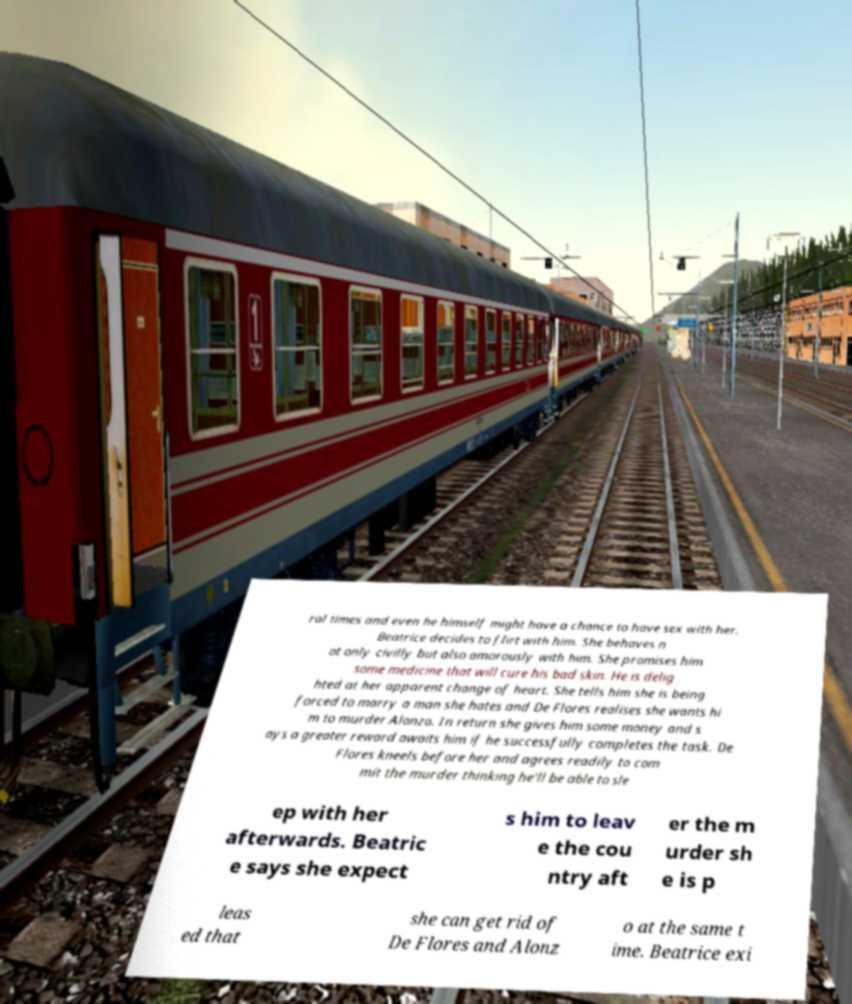What messages or text are displayed in this image? I need them in a readable, typed format. ral times and even he himself might have a chance to have sex with her. Beatrice decides to flirt with him. She behaves n ot only civilly but also amorously with him. She promises him some medicine that will cure his bad skin. He is delig hted at her apparent change of heart. She tells him she is being forced to marry a man she hates and De Flores realises she wants hi m to murder Alonzo. In return she gives him some money and s ays a greater reward awaits him if he successfully completes the task. De Flores kneels before her and agrees readily to com mit the murder thinking he'll be able to sle ep with her afterwards. Beatric e says she expect s him to leav e the cou ntry aft er the m urder sh e is p leas ed that she can get rid of De Flores and Alonz o at the same t ime. Beatrice exi 